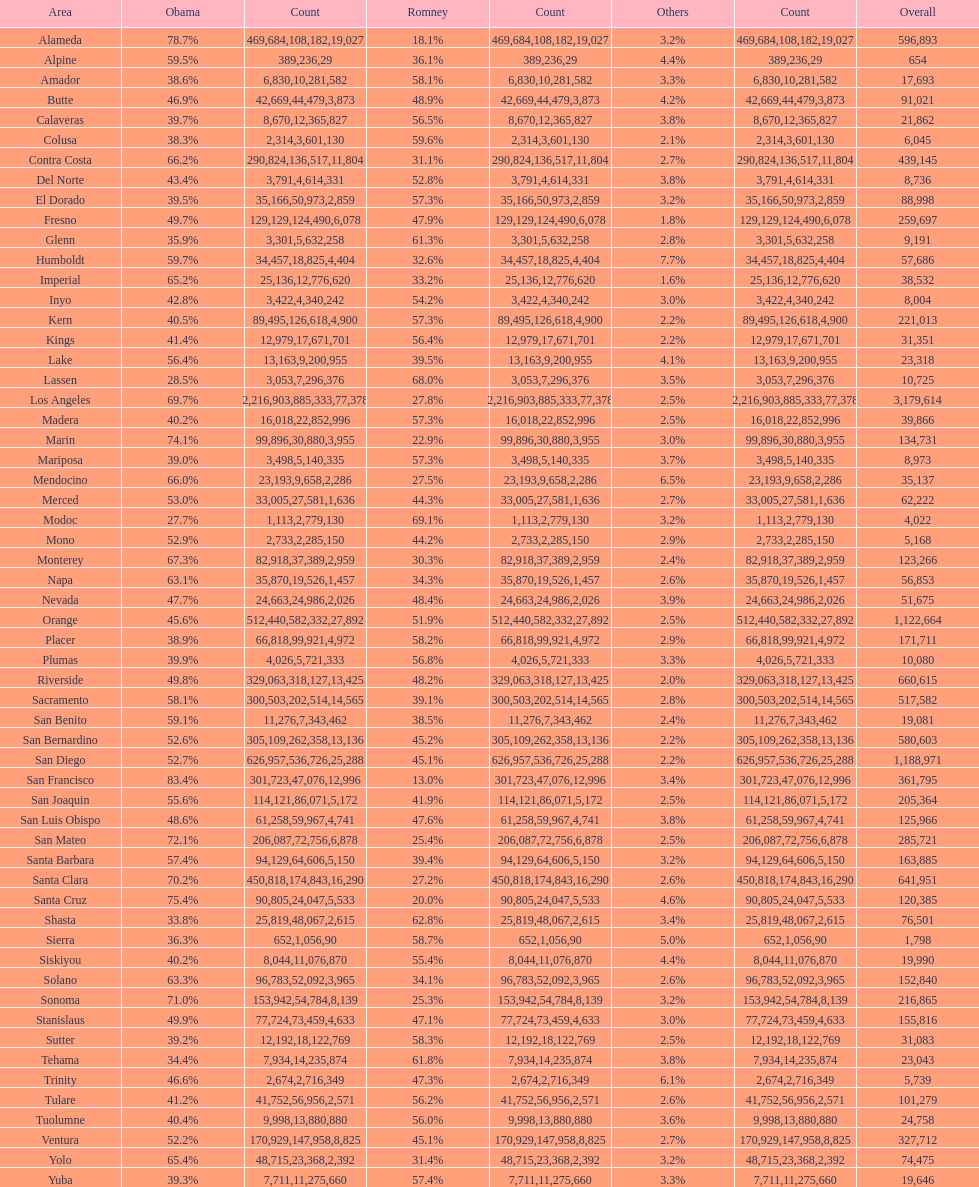Did romney earn more or less votes than obama did in alameda county? Less. 